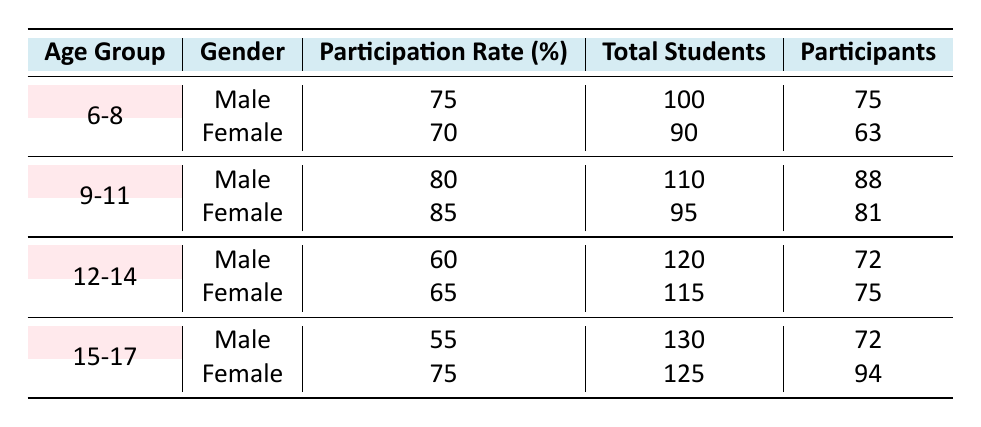What is the participation rate for females in the age group 12-14? Looking at the table, in the row for the age group 12-14 and gender Female, the participation rate listed is 65%.
Answer: 65 How many male students participate in the age group 6-8? In the age group 6-8 for males, the total number of students is 100, and the participation rate is 75%. To find the number of participating males, we calculate 75% of 100, which is 75.
Answer: 75 What is the difference in participation rates between males and females in the age group 15-17? In the age group 15-17, the male participation rate is 55% and the female rate is 75%. The difference is calculated by subtracting the male rate from the female rate: 75% - 55% = 20%.
Answer: 20 Is the participation rate for males in the age group 9-11 higher than that for females in the same age group? The participation rate for males in the age group 9-11 is 80%, while for females it is 85%. Since 80 is less than 85, the answer is no.
Answer: No What is the average participation rate across all age groups for female students? To find the average, we sum the female participation rates: 70% + 85% + 65% + 75% = 295%. There are 4 age groups, so we divide 295% by 4 to get the average: 295 / 4 = 73.75%.
Answer: 73.75 How many total students are there in the age group 12-14? In the table, the total number of students for age group 12-14 is the sum of male and female students, which is 120 (male) + 115 (female) = 235.
Answer: 235 Do more students (in total) participate in extracurricular activities in the age group 9-11 compared to the age group 15-17? For age group 9-11, the total students are 110 (male) + 95 (female) = 205. For age group 15-17, it is 130 (male) + 125 (female) = 255. Since 205 is less than 255, the answer is no.
Answer: No What percentage of total male students in the age group 6-8 participate in extracurricular activities? In the age group 6-8, there are 100 male students and 75 participate. To find the percentage of participating males, we take (75 / 100) * 100% = 75%.
Answer: 75 In which age group do male students have the lowest participation rate? From the table, the participation rates for males are 75% (6-8), 80% (9-11), 60% (12-14), and 55% (15-17). The lowest rate is 55%, which corresponds to the age group 15-17.
Answer: 15-17 